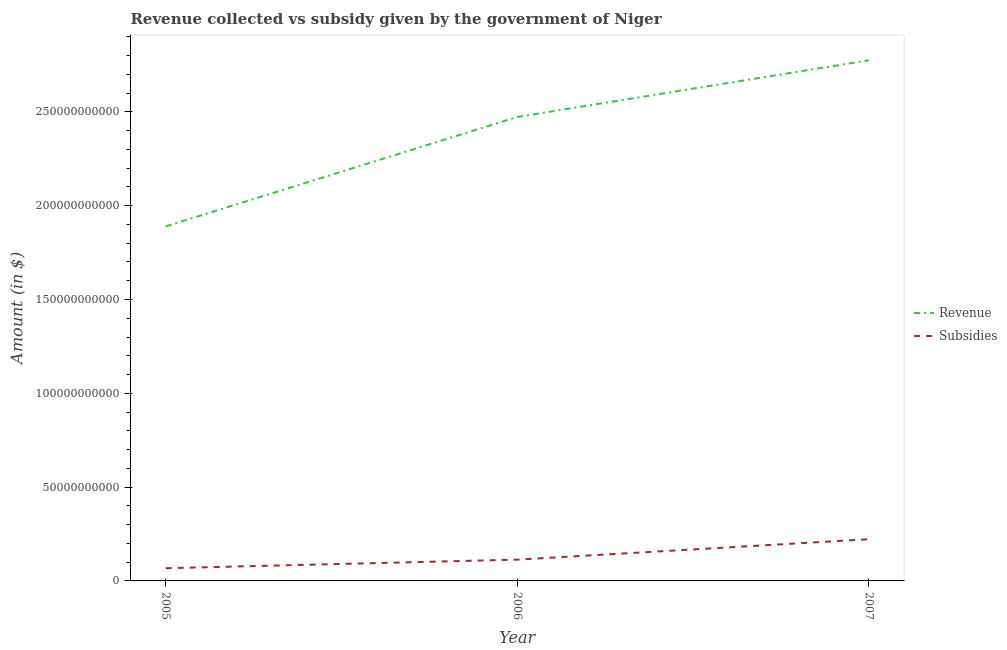How many different coloured lines are there?
Provide a succinct answer. 2. What is the amount of subsidies given in 2007?
Make the answer very short. 2.22e+1. Across all years, what is the maximum amount of revenue collected?
Provide a short and direct response. 2.78e+11. Across all years, what is the minimum amount of revenue collected?
Your response must be concise. 1.89e+11. In which year was the amount of revenue collected minimum?
Ensure brevity in your answer.  2005. What is the total amount of subsidies given in the graph?
Your answer should be compact. 4.03e+1. What is the difference between the amount of subsidies given in 2006 and that in 2007?
Provide a succinct answer. -1.09e+1. What is the difference between the amount of revenue collected in 2005 and the amount of subsidies given in 2006?
Ensure brevity in your answer.  1.78e+11. What is the average amount of revenue collected per year?
Keep it short and to the point. 2.38e+11. In the year 2006, what is the difference between the amount of revenue collected and amount of subsidies given?
Your answer should be compact. 2.36e+11. What is the ratio of the amount of subsidies given in 2005 to that in 2007?
Give a very brief answer. 0.3. Is the amount of revenue collected in 2005 less than that in 2006?
Ensure brevity in your answer.  Yes. Is the difference between the amount of subsidies given in 2005 and 2007 greater than the difference between the amount of revenue collected in 2005 and 2007?
Make the answer very short. Yes. What is the difference between the highest and the second highest amount of subsidies given?
Give a very brief answer. 1.09e+1. What is the difference between the highest and the lowest amount of revenue collected?
Make the answer very short. 8.85e+1. In how many years, is the amount of subsidies given greater than the average amount of subsidies given taken over all years?
Your answer should be compact. 1. Is the sum of the amount of revenue collected in 2006 and 2007 greater than the maximum amount of subsidies given across all years?
Give a very brief answer. Yes. Is the amount of subsidies given strictly greater than the amount of revenue collected over the years?
Your response must be concise. No. Is the amount of revenue collected strictly less than the amount of subsidies given over the years?
Your answer should be very brief. No. How many lines are there?
Offer a very short reply. 2. How many years are there in the graph?
Your answer should be very brief. 3. Does the graph contain grids?
Your response must be concise. No. How many legend labels are there?
Provide a short and direct response. 2. What is the title of the graph?
Provide a succinct answer. Revenue collected vs subsidy given by the government of Niger. Does "Commercial service imports" appear as one of the legend labels in the graph?
Keep it short and to the point. No. What is the label or title of the X-axis?
Make the answer very short. Year. What is the label or title of the Y-axis?
Offer a terse response. Amount (in $). What is the Amount (in $) in Revenue in 2005?
Offer a terse response. 1.89e+11. What is the Amount (in $) in Subsidies in 2005?
Your answer should be very brief. 6.76e+09. What is the Amount (in $) in Revenue in 2006?
Ensure brevity in your answer.  2.47e+11. What is the Amount (in $) of Subsidies in 2006?
Your response must be concise. 1.14e+1. What is the Amount (in $) of Revenue in 2007?
Offer a very short reply. 2.78e+11. What is the Amount (in $) of Subsidies in 2007?
Ensure brevity in your answer.  2.22e+1. Across all years, what is the maximum Amount (in $) of Revenue?
Ensure brevity in your answer.  2.78e+11. Across all years, what is the maximum Amount (in $) of Subsidies?
Ensure brevity in your answer.  2.22e+1. Across all years, what is the minimum Amount (in $) in Revenue?
Your response must be concise. 1.89e+11. Across all years, what is the minimum Amount (in $) in Subsidies?
Make the answer very short. 6.76e+09. What is the total Amount (in $) in Revenue in the graph?
Give a very brief answer. 7.14e+11. What is the total Amount (in $) of Subsidies in the graph?
Keep it short and to the point. 4.03e+1. What is the difference between the Amount (in $) in Revenue in 2005 and that in 2006?
Keep it short and to the point. -5.83e+1. What is the difference between the Amount (in $) in Subsidies in 2005 and that in 2006?
Offer a very short reply. -4.59e+09. What is the difference between the Amount (in $) in Revenue in 2005 and that in 2007?
Offer a very short reply. -8.85e+1. What is the difference between the Amount (in $) of Subsidies in 2005 and that in 2007?
Offer a terse response. -1.55e+1. What is the difference between the Amount (in $) in Revenue in 2006 and that in 2007?
Your response must be concise. -3.02e+1. What is the difference between the Amount (in $) in Subsidies in 2006 and that in 2007?
Offer a terse response. -1.09e+1. What is the difference between the Amount (in $) of Revenue in 2005 and the Amount (in $) of Subsidies in 2006?
Your response must be concise. 1.78e+11. What is the difference between the Amount (in $) in Revenue in 2005 and the Amount (in $) in Subsidies in 2007?
Provide a short and direct response. 1.67e+11. What is the difference between the Amount (in $) of Revenue in 2006 and the Amount (in $) of Subsidies in 2007?
Provide a succinct answer. 2.25e+11. What is the average Amount (in $) of Revenue per year?
Provide a succinct answer. 2.38e+11. What is the average Amount (in $) of Subsidies per year?
Make the answer very short. 1.34e+1. In the year 2005, what is the difference between the Amount (in $) of Revenue and Amount (in $) of Subsidies?
Your answer should be very brief. 1.82e+11. In the year 2006, what is the difference between the Amount (in $) in Revenue and Amount (in $) in Subsidies?
Your response must be concise. 2.36e+11. In the year 2007, what is the difference between the Amount (in $) in Revenue and Amount (in $) in Subsidies?
Your response must be concise. 2.55e+11. What is the ratio of the Amount (in $) of Revenue in 2005 to that in 2006?
Provide a short and direct response. 0.76. What is the ratio of the Amount (in $) in Subsidies in 2005 to that in 2006?
Offer a very short reply. 0.6. What is the ratio of the Amount (in $) of Revenue in 2005 to that in 2007?
Keep it short and to the point. 0.68. What is the ratio of the Amount (in $) of Subsidies in 2005 to that in 2007?
Offer a very short reply. 0.3. What is the ratio of the Amount (in $) in Revenue in 2006 to that in 2007?
Make the answer very short. 0.89. What is the ratio of the Amount (in $) in Subsidies in 2006 to that in 2007?
Offer a very short reply. 0.51. What is the difference between the highest and the second highest Amount (in $) of Revenue?
Your answer should be compact. 3.02e+1. What is the difference between the highest and the second highest Amount (in $) of Subsidies?
Give a very brief answer. 1.09e+1. What is the difference between the highest and the lowest Amount (in $) in Revenue?
Provide a short and direct response. 8.85e+1. What is the difference between the highest and the lowest Amount (in $) in Subsidies?
Ensure brevity in your answer.  1.55e+1. 